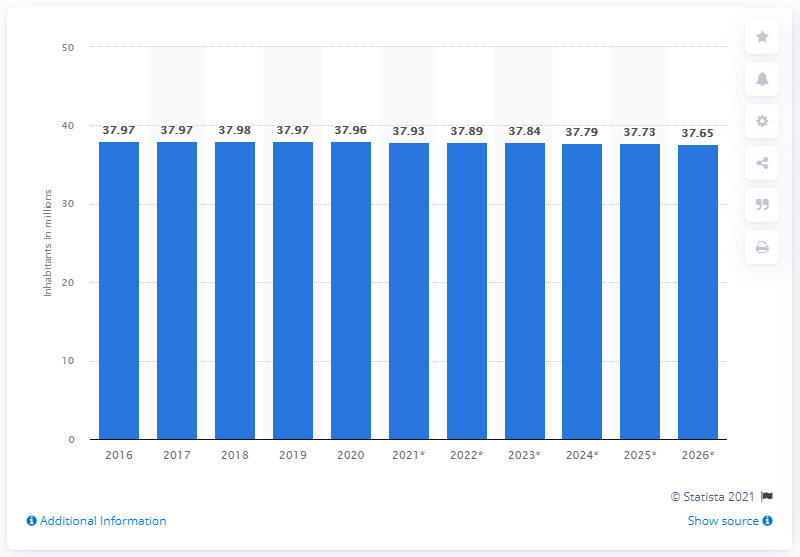What was the population of Poland in 2020? In 2020, the population of Poland was approximately 37.98 million according to the data shown in the bar chart. The chart provides a year-by-year representation of Poland's population, indicating a slight decline over several years from 2016. 